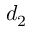<formula> <loc_0><loc_0><loc_500><loc_500>d _ { 2 }</formula> 